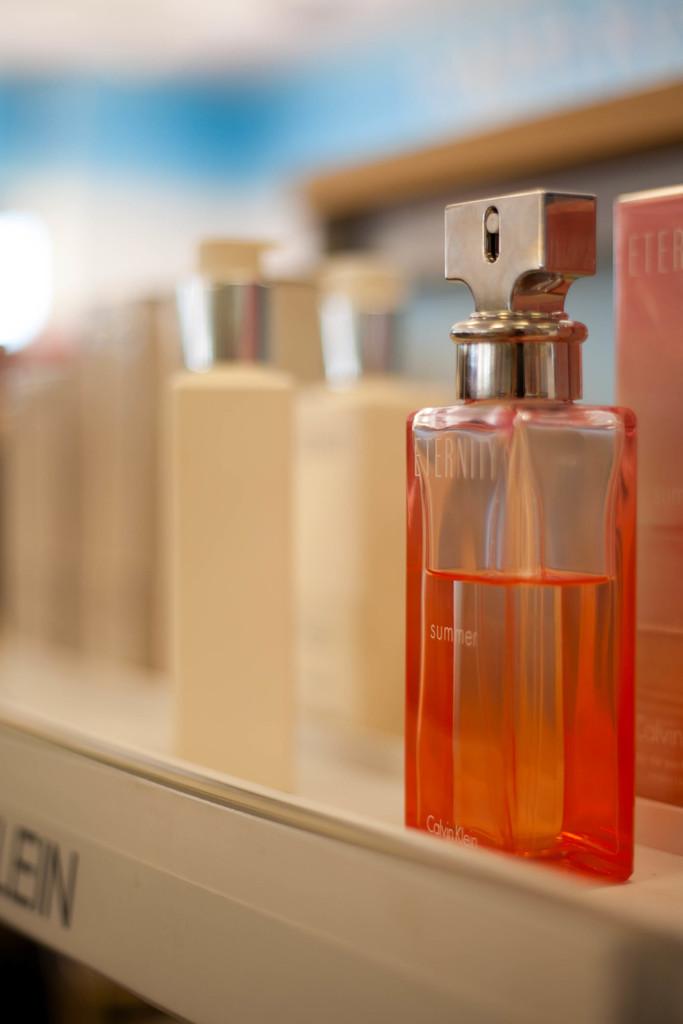What are the last 3 letters on the shelf?
Your answer should be very brief. Ein. 